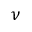<formula> <loc_0><loc_0><loc_500><loc_500>\nu</formula> 